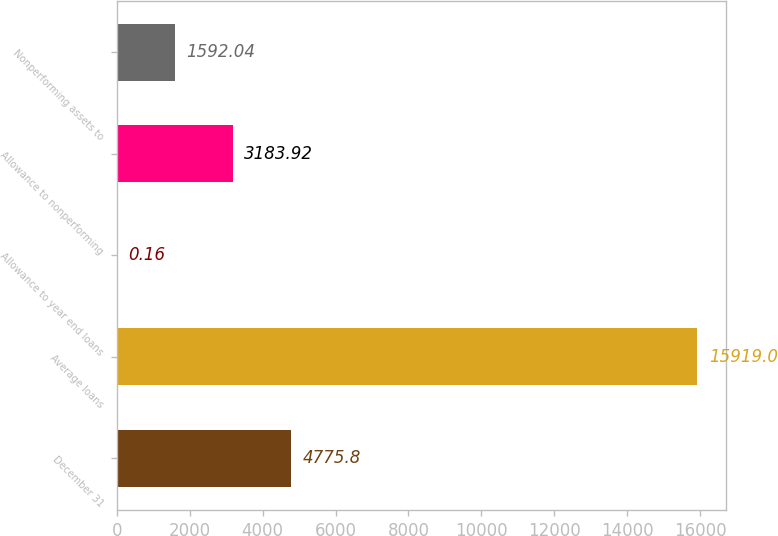<chart> <loc_0><loc_0><loc_500><loc_500><bar_chart><fcel>December 31<fcel>Average loans<fcel>Allowance to year end loans<fcel>Allowance to nonperforming<fcel>Nonperforming assets to<nl><fcel>4775.8<fcel>15919<fcel>0.16<fcel>3183.92<fcel>1592.04<nl></chart> 